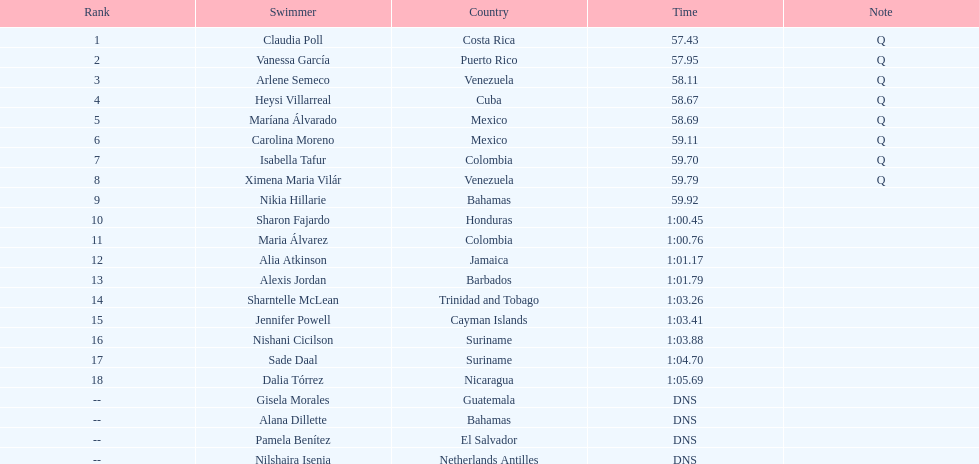How many swimmers did not swim? 4. 